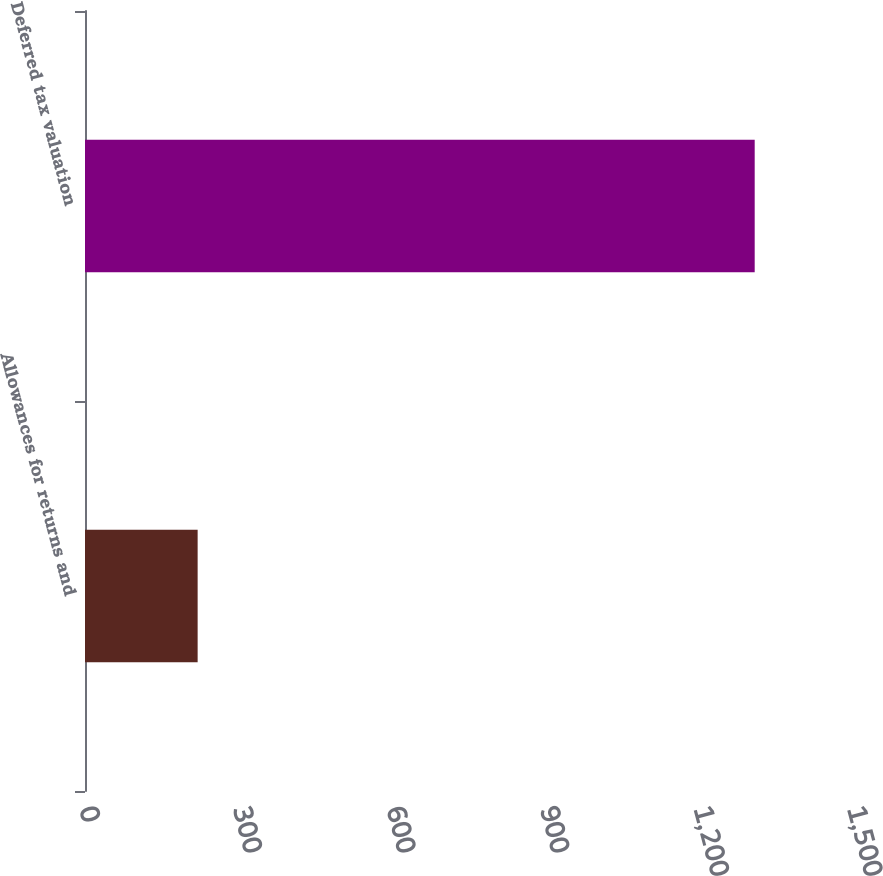<chart> <loc_0><loc_0><loc_500><loc_500><bar_chart><fcel>Allowances for returns and<fcel>Deferred tax valuation<nl><fcel>220<fcel>1308<nl></chart> 